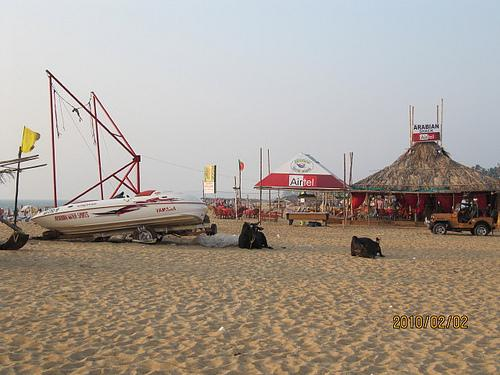What type of geographical feature is located near this area?

Choices:
A) desert
B) ocean
C) mountain
D) mesa ocean 